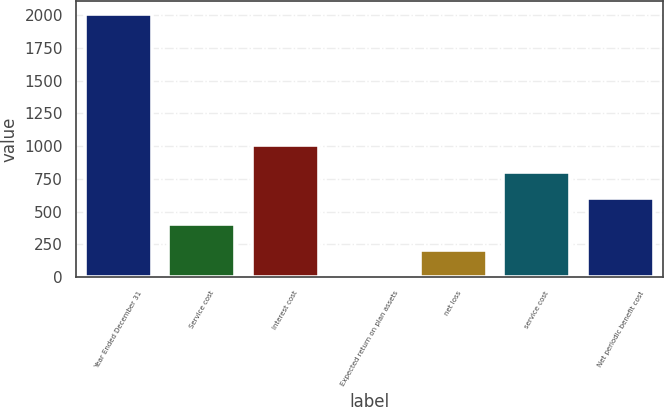Convert chart. <chart><loc_0><loc_0><loc_500><loc_500><bar_chart><fcel>Year Ended December 31<fcel>Service cost<fcel>Interest cost<fcel>Expected return on plan assets<fcel>net loss<fcel>service cost<fcel>Net periodic benefit cost<nl><fcel>2005<fcel>405<fcel>1005<fcel>5<fcel>205<fcel>805<fcel>605<nl></chart> 